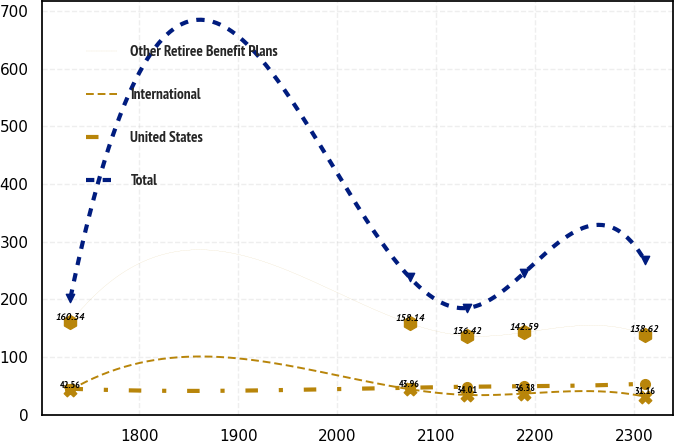Convert chart to OTSL. <chart><loc_0><loc_0><loc_500><loc_500><line_chart><ecel><fcel>Other Retiree Benefit Plans<fcel>International<fcel>United States<fcel>Total<nl><fcel>1730.58<fcel>160.34<fcel>42.56<fcel>44.8<fcel>202.78<nl><fcel>2073.14<fcel>158.14<fcel>43.96<fcel>46.72<fcel>238.09<nl><fcel>2131.12<fcel>136.42<fcel>34.01<fcel>48.23<fcel>184.88<nl><fcel>2189.1<fcel>142.59<fcel>36.38<fcel>49.09<fcel>246.43<nl><fcel>2310.37<fcel>138.62<fcel>31.16<fcel>53.41<fcel>268.26<nl></chart> 